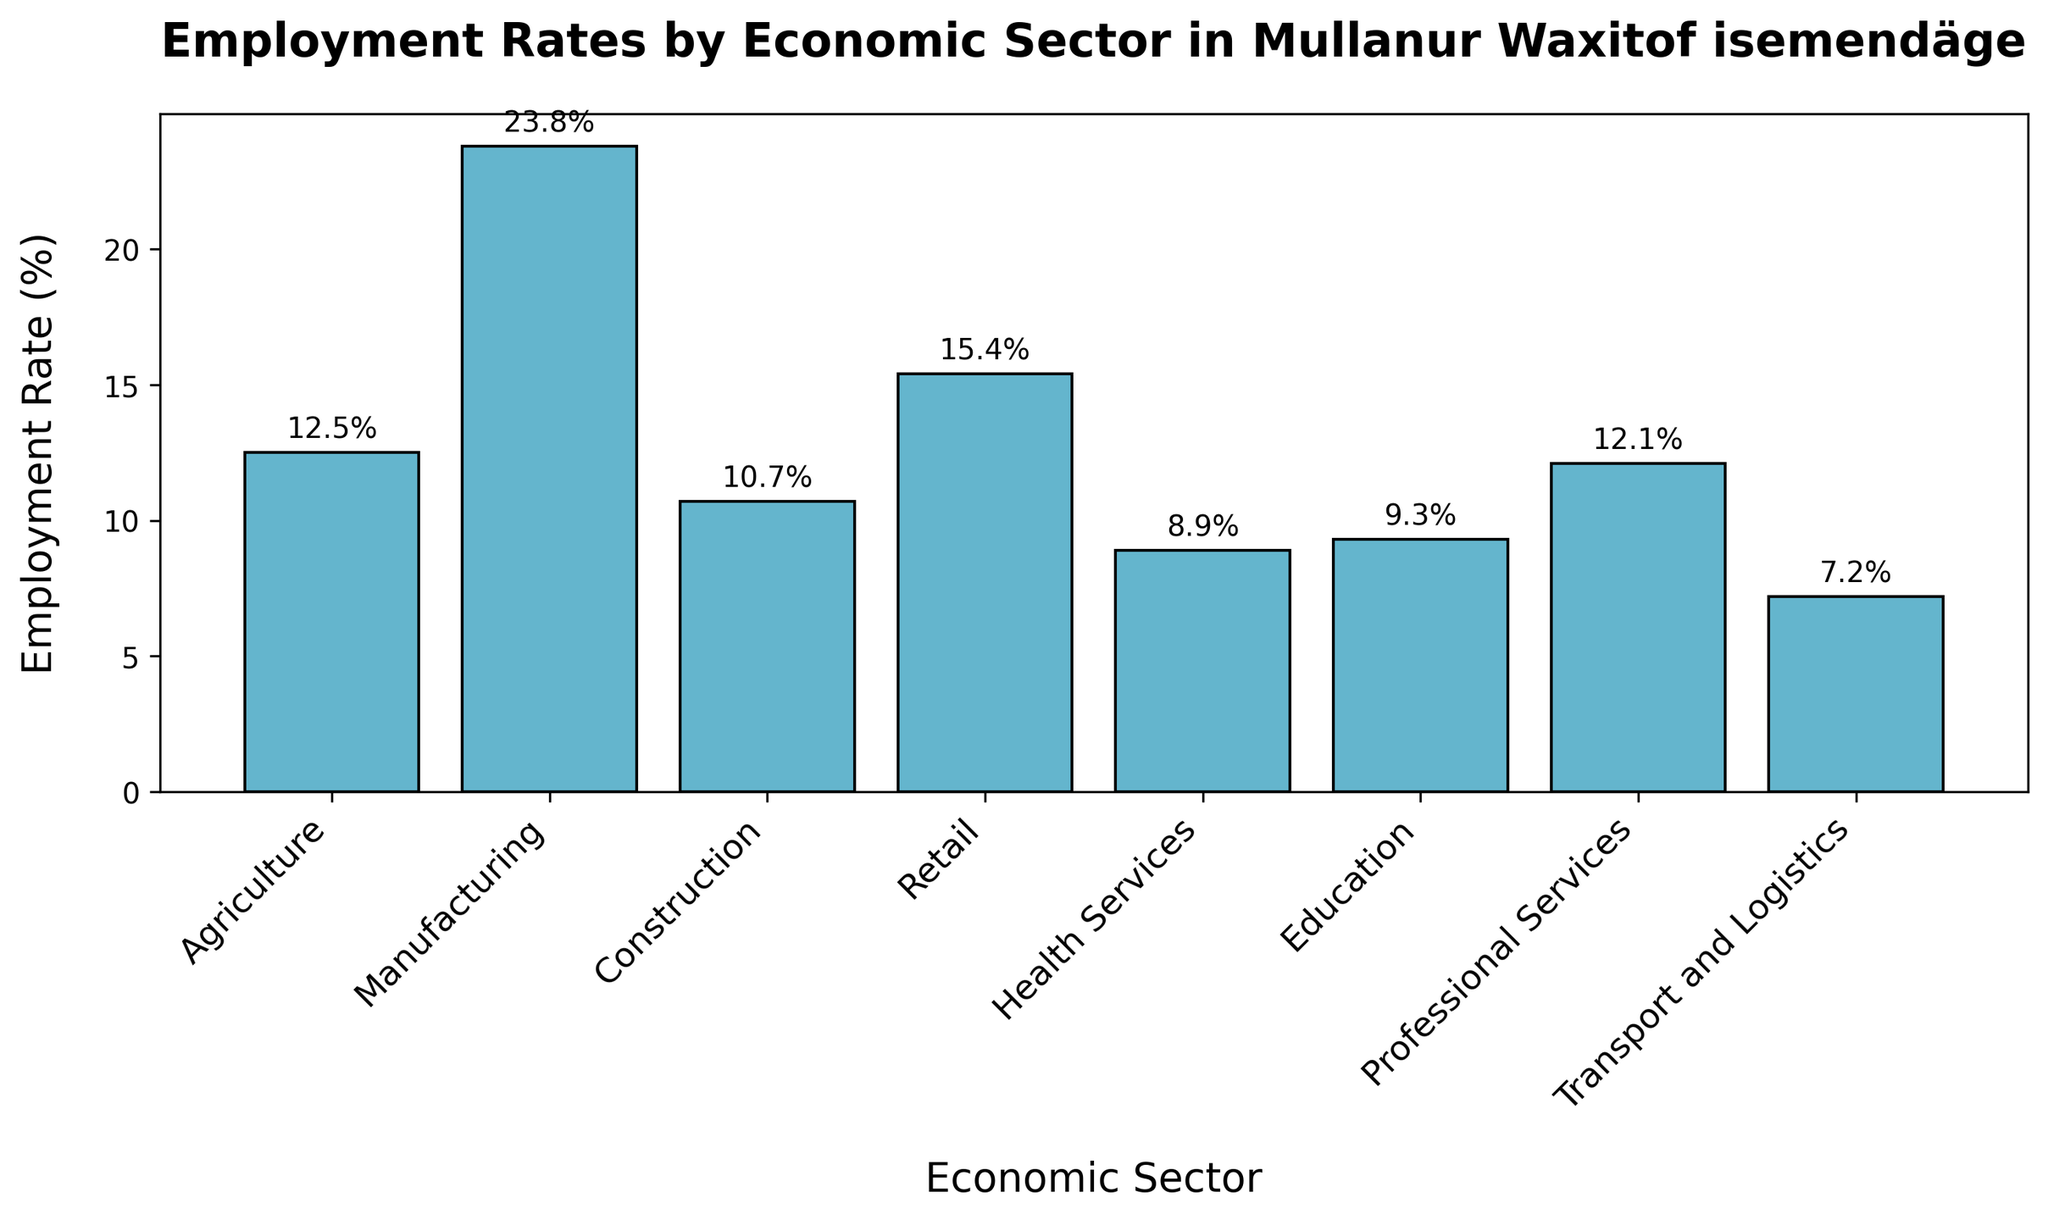Which sector has the highest employment rate? By observing the heights of the bars, Manufacturing is the tallest bar, corresponding to the highest employment rate.
Answer: Manufacturing Which sector has the lowest employment rate? Looking at the heights of the bars, Transport and Logistics is the shortest, indicating it has the lowest employment rate.
Answer: Transport and Logistics What is the combined employment rate for Agriculture and Retail? The employment rates are 12.5% for Agriculture and 15.4% for Retail. Adding these together gives 12.5% + 15.4% = 27.9%.
Answer: 27.9% How much greater is the employment rate in Manufacturing compared to Health Services? The employment rate for Manufacturing is 23.8% and for Health Services is 8.9%. Subtracting these gives 23.8% - 8.9% = 14.9%.
Answer: 14.9% Which sectors have employment rates over 10%? Observing the chart, the sectors with employment rates over 10% are Agriculture, Manufacturing, Construction, Retail, and Professional Services.
Answer: Agriculture, Manufacturing, Construction, Retail, Professional Services What is the difference in employment rates between Retail and Education? The employment rate for Retail is 15.4% and for Education is 9.3%. Subtracting these gives 15.4% - 9.3% = 6.1%.
Answer: 6.1% Is the employment rate in Professional Services higher or lower than in Agriculture? Comparing the bar heights, the employment rate in Professional Services (12.1%) is slightly lower than in Agriculture (12.5%).
Answer: Lower What is the average employment rate across all sectors? Adding all employment rates: 12.5 + 23.8 + 10.7 + 15.4 + 8.9 + 9.3 + 12.1 + 7.2 = 99.9. There are 8 sectors, so dividing 99.9 by 8 gives an average of 12.49%.
Answer: 12.49% How much greater is the employment rate in Professional Services than in Transport and Logistics? The employment rate in Professional Services is 12.1% and in Transport and Logistics is 7.2%. Subtracting these gives 12.1% - 7.2% = 4.9%.
Answer: 4.9% 